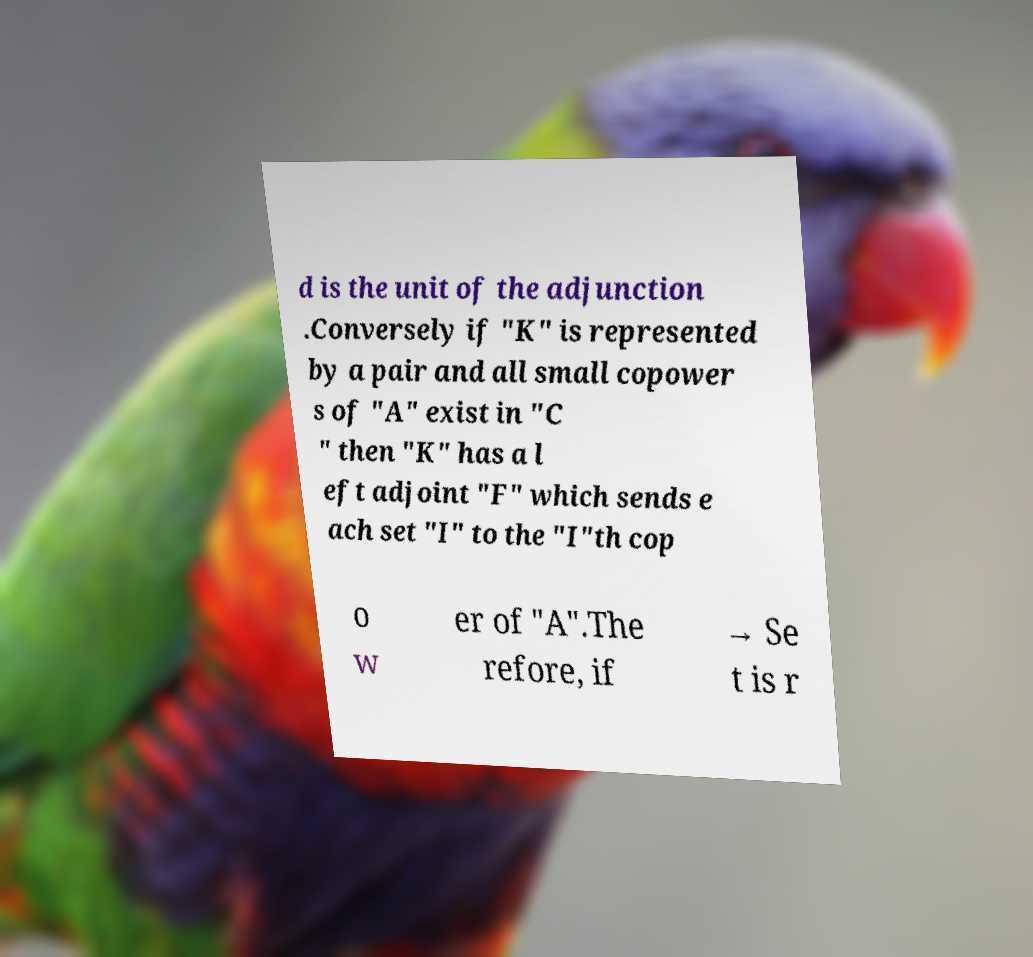What messages or text are displayed in this image? I need them in a readable, typed format. d is the unit of the adjunction .Conversely if "K" is represented by a pair and all small copower s of "A" exist in "C " then "K" has a l eft adjoint "F" which sends e ach set "I" to the "I"th cop o w er of "A".The refore, if → Se t is r 